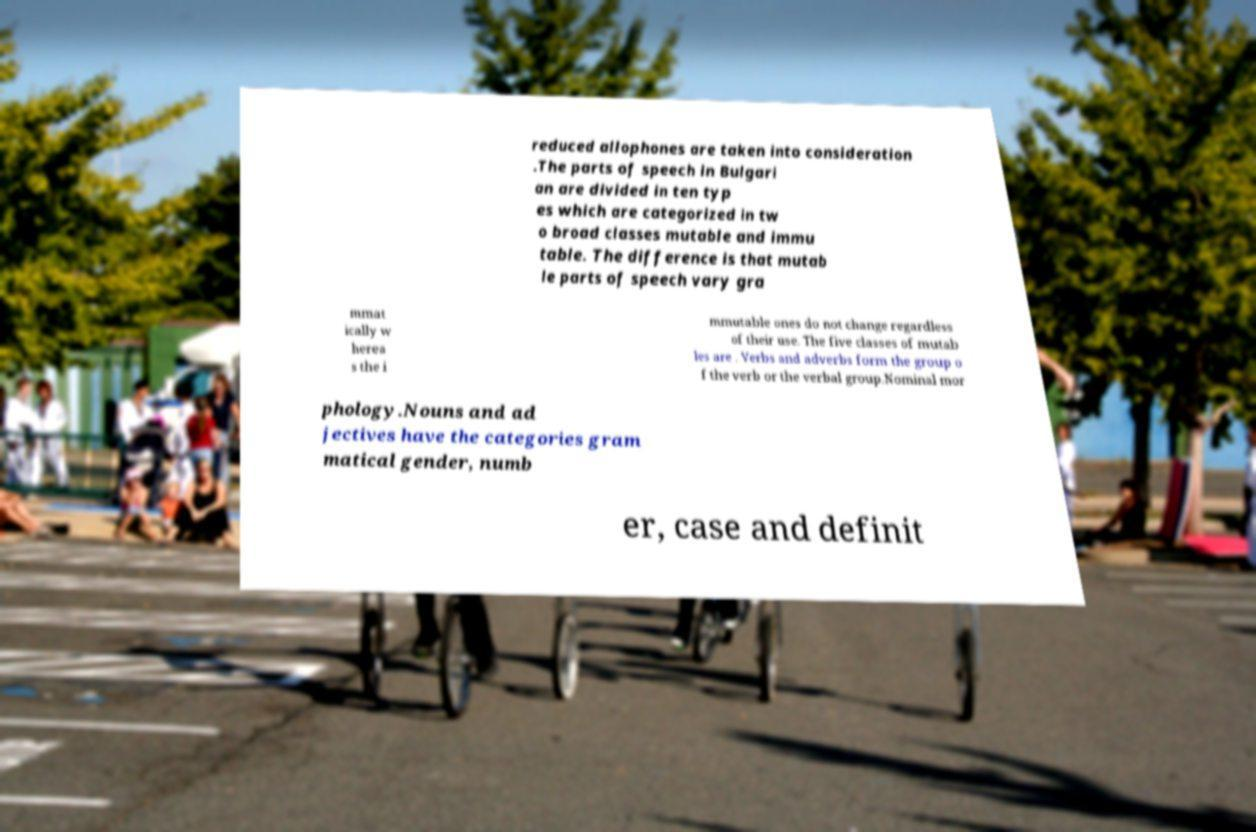I need the written content from this picture converted into text. Can you do that? reduced allophones are taken into consideration .The parts of speech in Bulgari an are divided in ten typ es which are categorized in tw o broad classes mutable and immu table. The difference is that mutab le parts of speech vary gra mmat ically w herea s the i mmutable ones do not change regardless of their use. The five classes of mutab les are . Verbs and adverbs form the group o f the verb or the verbal group.Nominal mor phology.Nouns and ad jectives have the categories gram matical gender, numb er, case and definit 